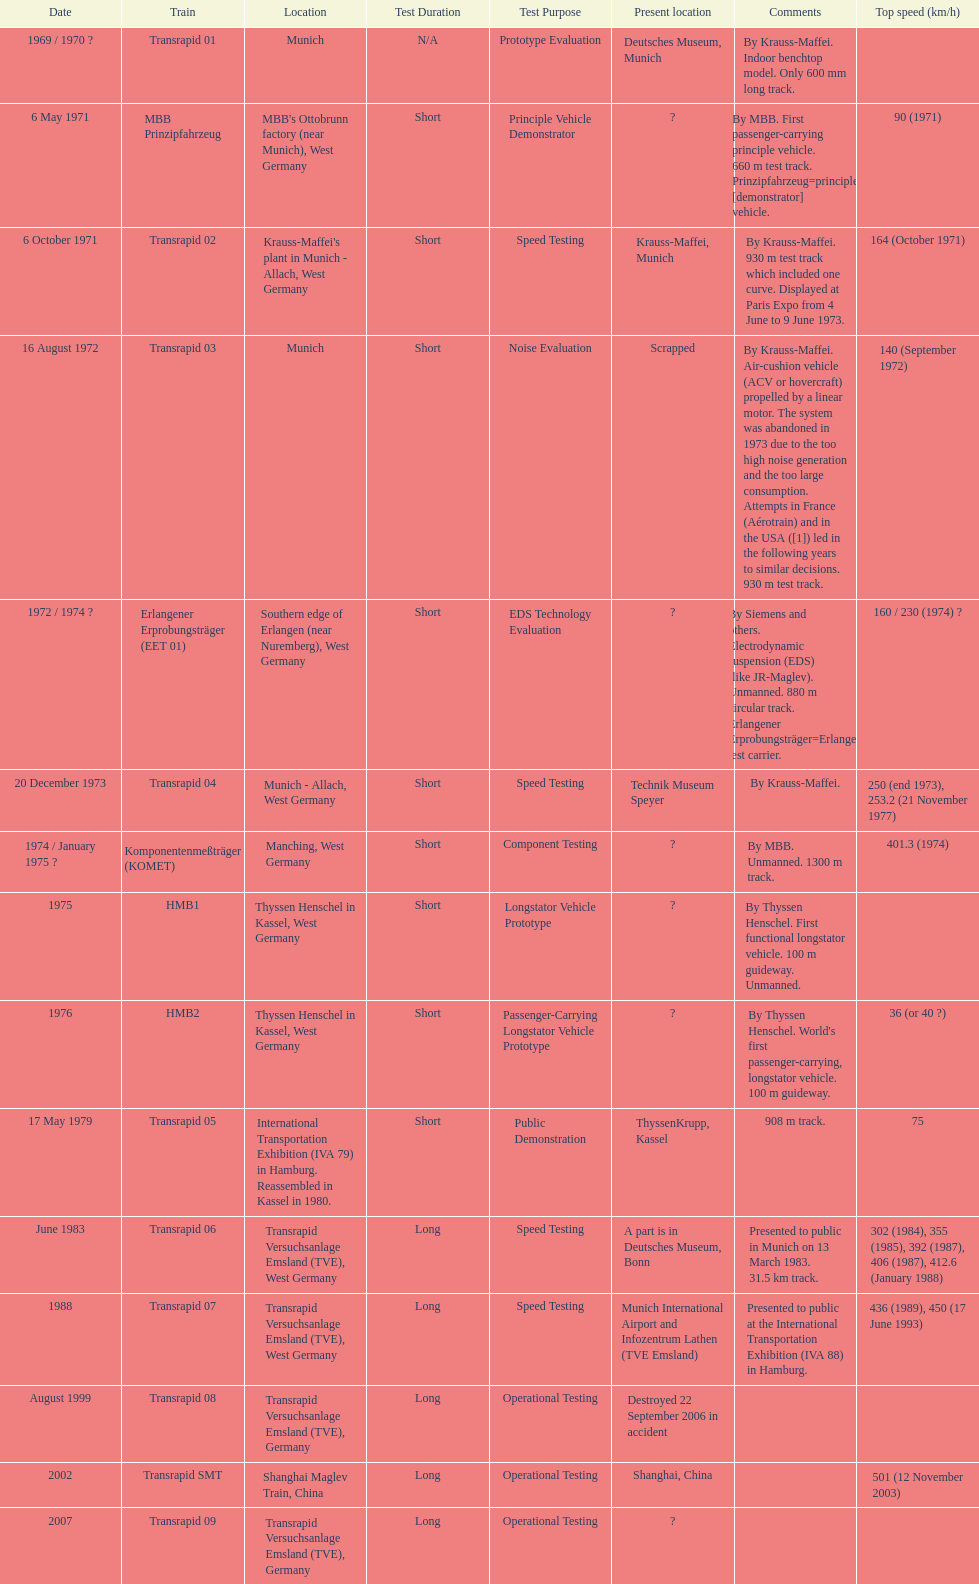Which train has the least top speed? HMB2. 